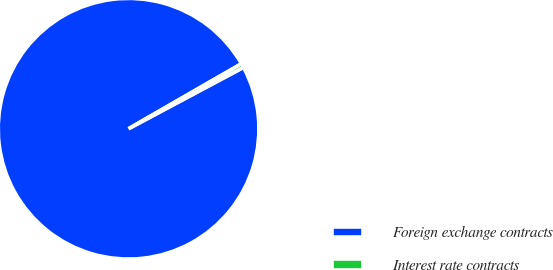Convert chart to OTSL. <chart><loc_0><loc_0><loc_500><loc_500><pie_chart><fcel>Foreign exchange contracts<fcel>Interest rate contracts<nl><fcel>99.49%<fcel>0.51%<nl></chart> 